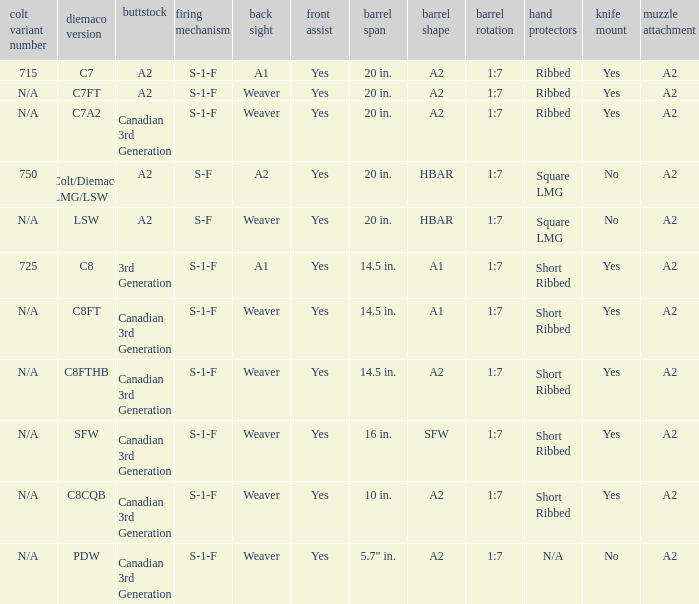Would you be able to parse every entry in this table? {'header': ['colt variant number', 'diemaco version', 'buttstock', 'firing mechanism', 'back sight', 'front assist', 'barrel span', 'barrel shape', 'barrel rotation', 'hand protectors', 'knife mount', 'muzzle attachment'], 'rows': [['715', 'C7', 'A2', 'S-1-F', 'A1', 'Yes', '20 in.', 'A2', '1:7', 'Ribbed', 'Yes', 'A2'], ['N/A', 'C7FT', 'A2', 'S-1-F', 'Weaver', 'Yes', '20 in.', 'A2', '1:7', 'Ribbed', 'Yes', 'A2'], ['N/A', 'C7A2', 'Canadian 3rd Generation', 'S-1-F', 'Weaver', 'Yes', '20 in.', 'A2', '1:7', 'Ribbed', 'Yes', 'A2'], ['750', 'Colt/Diemaco LMG/LSW', 'A2', 'S-F', 'A2', 'Yes', '20 in.', 'HBAR', '1:7', 'Square LMG', 'No', 'A2'], ['N/A', 'LSW', 'A2', 'S-F', 'Weaver', 'Yes', '20 in.', 'HBAR', '1:7', 'Square LMG', 'No', 'A2'], ['725', 'C8', '3rd Generation', 'S-1-F', 'A1', 'Yes', '14.5 in.', 'A1', '1:7', 'Short Ribbed', 'Yes', 'A2'], ['N/A', 'C8FT', 'Canadian 3rd Generation', 'S-1-F', 'Weaver', 'Yes', '14.5 in.', 'A1', '1:7', 'Short Ribbed', 'Yes', 'A2'], ['N/A', 'C8FTHB', 'Canadian 3rd Generation', 'S-1-F', 'Weaver', 'Yes', '14.5 in.', 'A2', '1:7', 'Short Ribbed', 'Yes', 'A2'], ['N/A', 'SFW', 'Canadian 3rd Generation', 'S-1-F', 'Weaver', 'Yes', '16 in.', 'SFW', '1:7', 'Short Ribbed', 'Yes', 'A2'], ['N/A', 'C8CQB', 'Canadian 3rd Generation', 'S-1-F', 'Weaver', 'Yes', '10 in.', 'A2', '1:7', 'Short Ribbed', 'Yes', 'A2'], ['N/A', 'PDW', 'Canadian 3rd Generation', 'S-1-F', 'Weaver', 'Yes', '5.7" in.', 'A2', '1:7', 'N/A', 'No', 'A2']]} Which Hand guards has a Barrel profile of a2 and a Rear sight of weaver? Ribbed, Ribbed, Short Ribbed, Short Ribbed, N/A. 